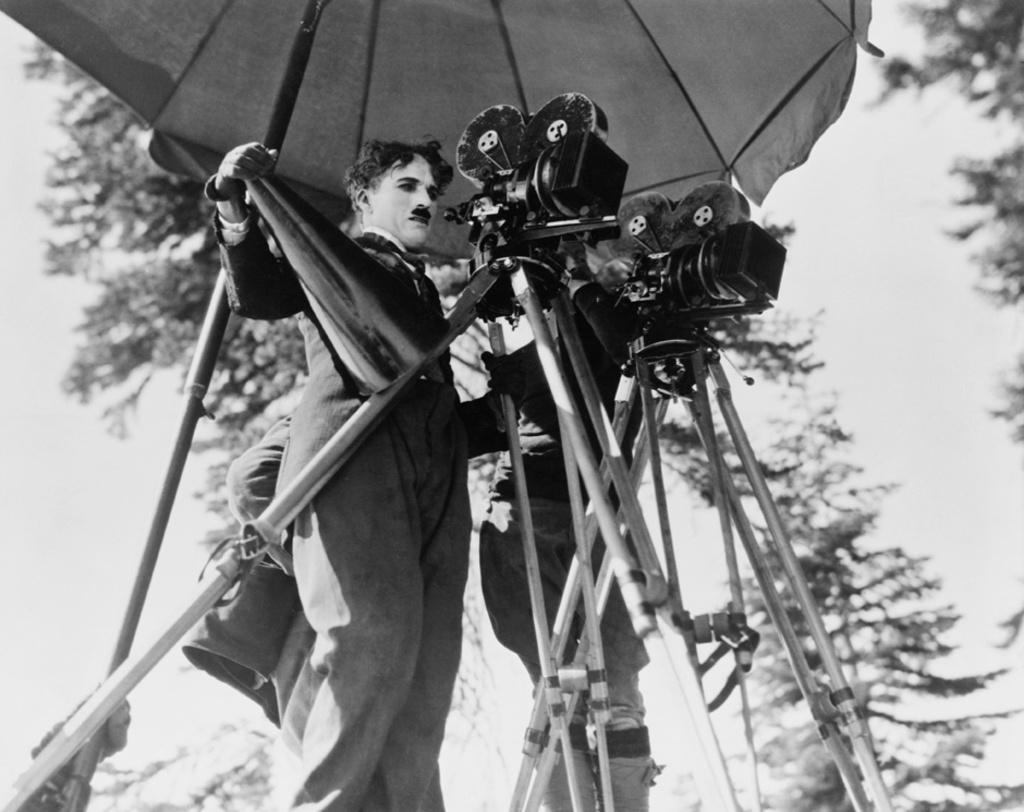How many people are in the image? There are persons in the image, but the exact number is not specified. What are the cameras with stands used for in the image? The cameras with stands are in front of the persons, suggesting they are being photographed or filmed. What type of natural scenery can be seen behind the persons? There are trees visible behind the persons. What object is at the top of the image? There is an umbrella at the top of the image. What type of rings are being exchanged between the persons in the image? There is no mention of rings or any exchange of objects in the image. --- Facts: 1. There is a person holding a book in the image. 2. The book has a blue cover. 3. The person is sitting on a chair. 4. There is a table next to the chair. 5. The table has a lamp on it. Absurd Topics: parrot, ocean, bicycle Conversation: What is the person holding in the image? The person is holding a book in the image. What color is the book's cover? The book has a blue cover. What type of furniture is the person sitting on? The person is sitting on a chair. What object is next to the chair? There is a table next to the chair. What is on the table? The table has a lamp on it. Reasoning: Let's think step by step in order to produce the conversation. We start by identifying the main subject in the image, which is the person holding a book. Then, we expand the conversation to include details about the book, such as its color. Next, we describe the furniture the person is sitting on, which is a chair. We then mention the table next to the chair and the lamp on it. Each question is designed to elicit a specific detail about the image that is known from the provided facts. Absurd Question/Answer: Can you see a parrot sitting on the person's shoulder in the image? No, there is no parrot present in the image. 